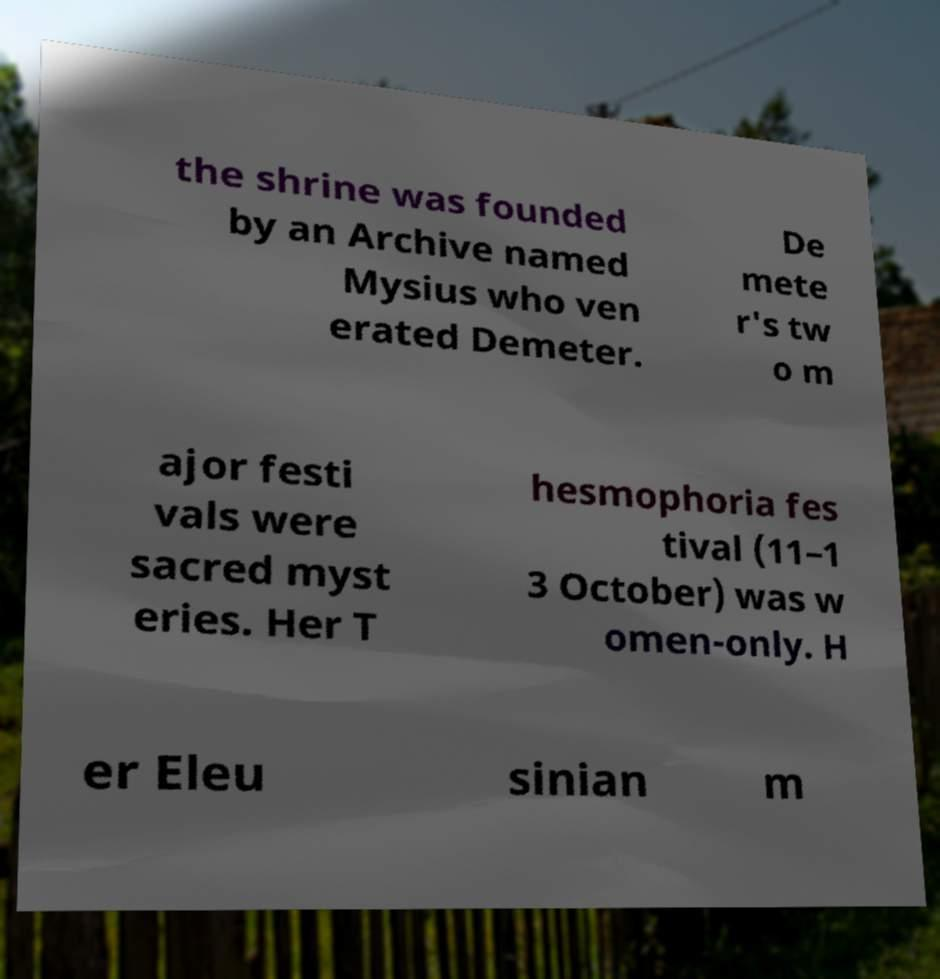There's text embedded in this image that I need extracted. Can you transcribe it verbatim? the shrine was founded by an Archive named Mysius who ven erated Demeter. De mete r's tw o m ajor festi vals were sacred myst eries. Her T hesmophoria fes tival (11–1 3 October) was w omen-only. H er Eleu sinian m 